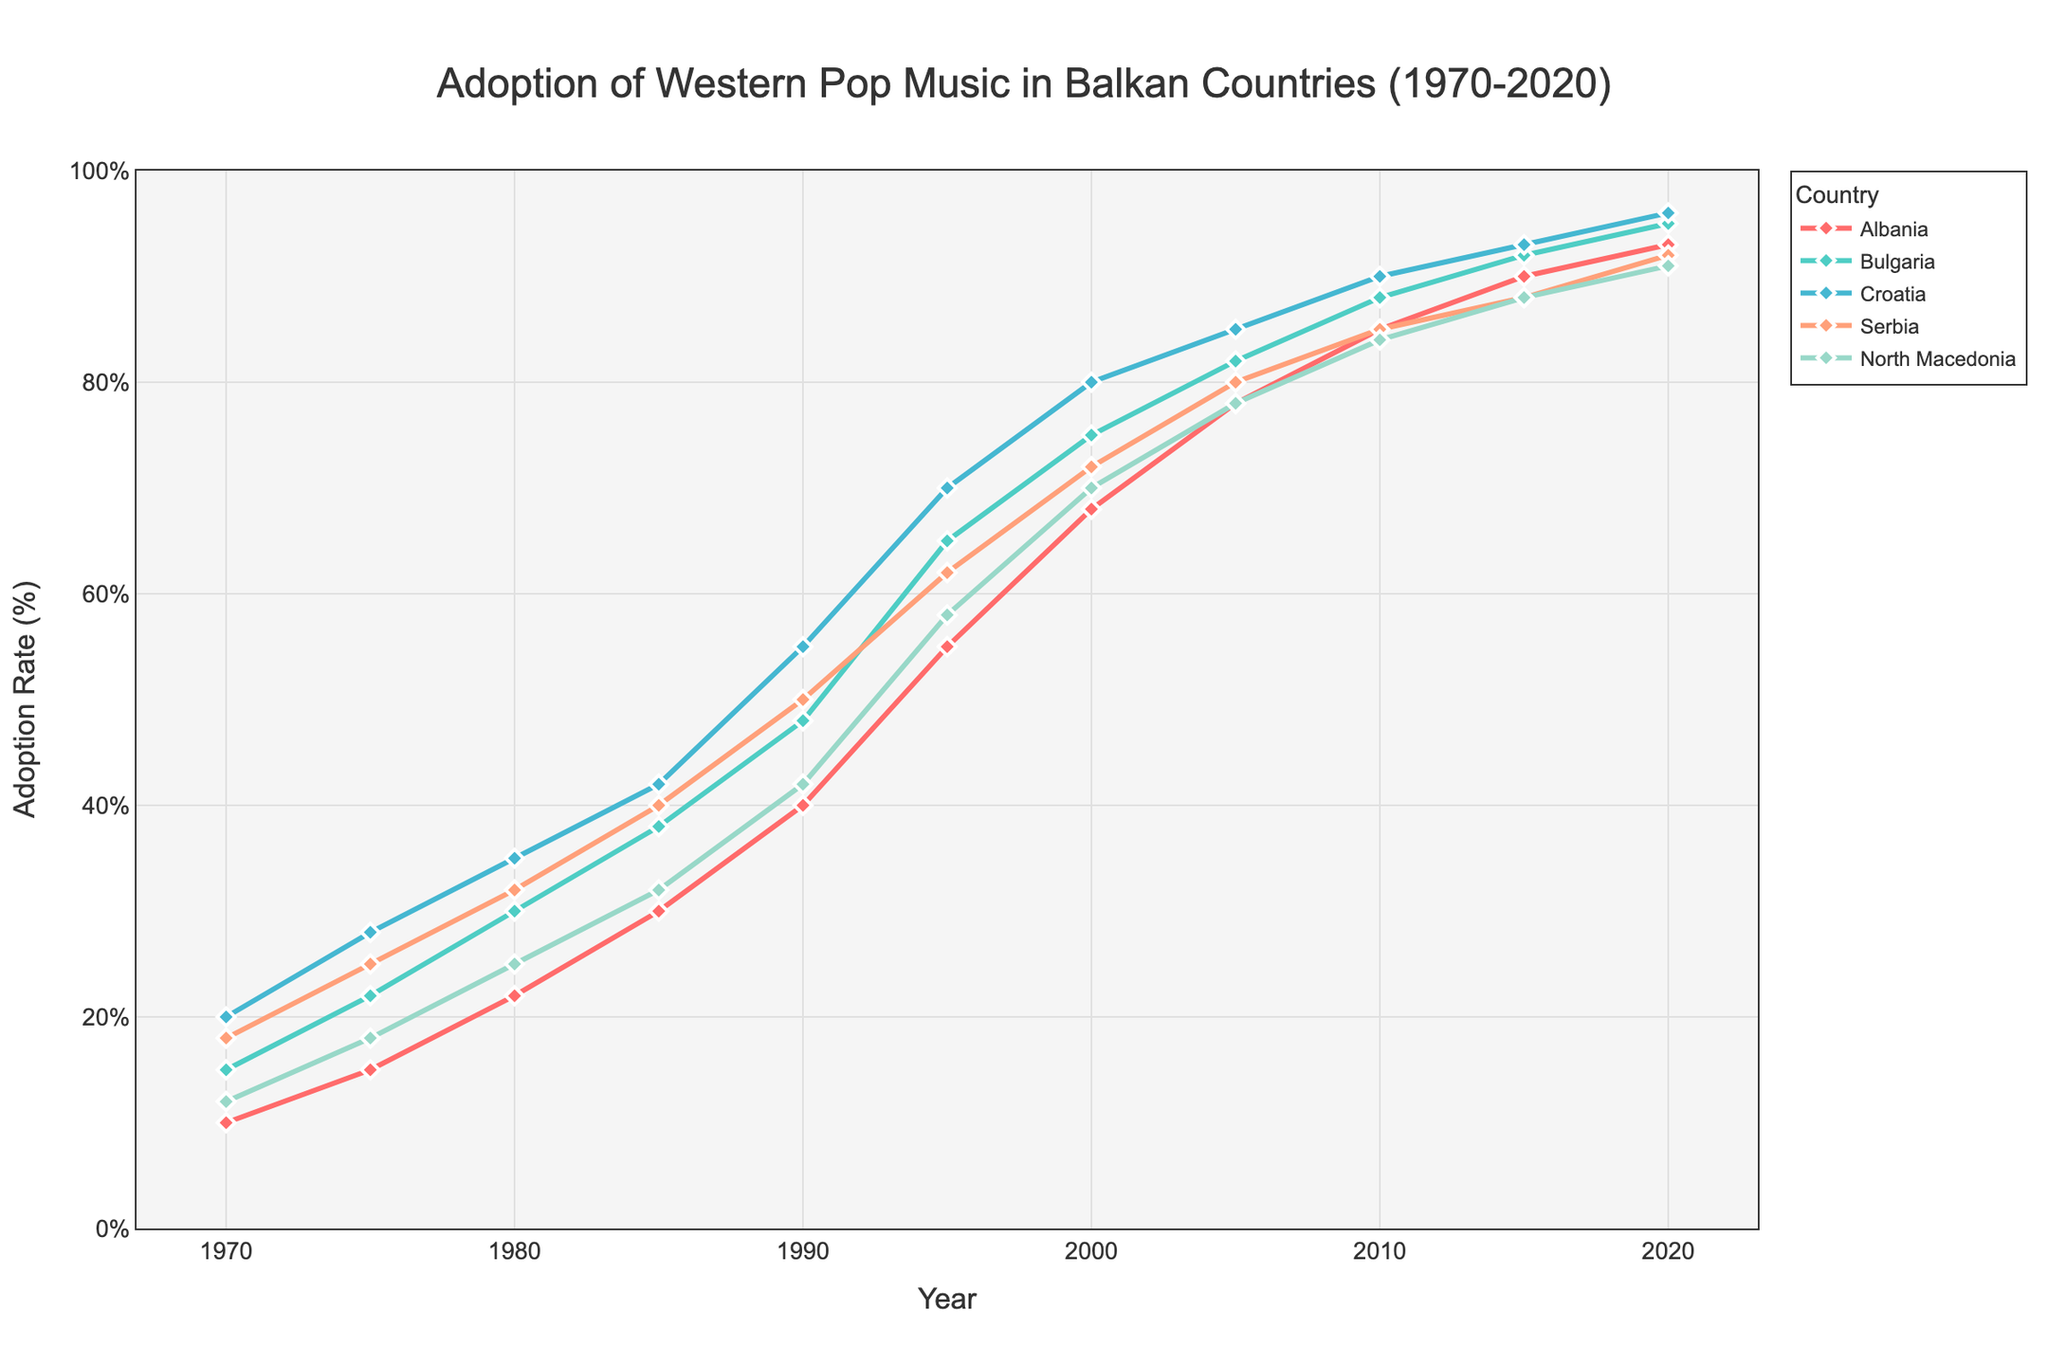What is the adoption rate of Western pop music in Serbia in the year 1995? The year 1995 corresponds to the adoption rate of Western pop music in Serbia indicated on the y-axis. The plotted data point for Serbia in 1995 can be directly observed on the graph.
Answer: 62% Which country had the highest adoption rate of Western pop music in 2020? By comparing the y-axis values of all countries in the year 2020, we can determine the highest adoption rate. The data point for each country in 2020 should be visually inspected.
Answer: Croatia Did Albania's adoption rate of Western pop music ever surpass 80%? By following Albania's plotted line on the graph and observing its y-axis values, we can determine if the adoption rate exceeded 80% at any point. Check for data points above the 80% mark.
Answer: Yes On average, what were the adoption rates of Western pop music in North Macedonia from 1970 to 2020? Sum the adoption rates for North Macedonia over the years from 1970 to 2020 and divide by the number of data points (11). Calculate the average: (12 + 18 + 25 + 32 + 42 + 58 + 70 + 78 + 84 + 88 + 91)/11.
Answer: 57.18% Between 1980 and 1995, which country showed the greatest increase in the adoption rate of Western pop music? Calculate the difference in adoption rates for each country between 1980 and 1995. Determine the greatest increase by comparing these differences: Albania (55-22 = 33), Bulgaria (65-30 = 35), Croatia (70-35 = 35), Serbia (62-32 = 30), North Macedonia (58-25 = 33).
Answer: Bulgaria & Croatia Which country had the lowest adoption rate of Western pop music in 1980? Visually inspect the plotted points for each country in 1980 and compare their y-axis values to find the lowest adoption rate.
Answer: Albania How did the adoption rate of Western pop music in Bulgaria change between 2005 and 2010? Identify the data points for Bulgaria in 2005 and 2010, then observe the change in y-axis values between these years: 88% - 82% = 6%.
Answer: Increased by 6% What was the combined adoption rate of Western pop music for Croatia and North Macedonia in 1970? Sum the adoption rates of both Croatia and North Macedonia for the year 1970: 20% + 12% = 32%.
Answer: 32% What is the trend of Western pop music adoption in Albania from 1970 to 2020? Observe the plotted line for Albania over the years, focusing on the direction and pattern of change: The line shows a consistent upward trend from 10% to 93%.
Answer: Consistently Increasing By how much did Serbia's adoption rate of Western pop music grow between 1975 and 1985? Identify Serbia’s adoption rates for 1975 and 1985, and calculate the difference: 40% - 25% = 15%.
Answer: 15% 